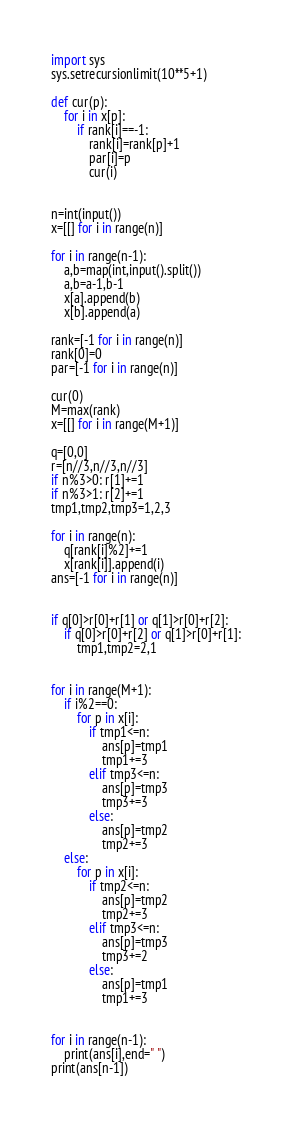<code> <loc_0><loc_0><loc_500><loc_500><_Python_>import sys
sys.setrecursionlimit(10**5+1)

def cur(p):
    for i in x[p]:
        if rank[i]==-1:
            rank[i]=rank[p]+1
            par[i]=p
            cur(i)


n=int(input())
x=[[] for i in range(n)]

for i in range(n-1):
    a,b=map(int,input().split())
    a,b=a-1,b-1
    x[a].append(b)
    x[b].append(a)

rank=[-1 for i in range(n)]
rank[0]=0
par=[-1 for i in range(n)]

cur(0)
M=max(rank)
x=[[] for i in range(M+1)]

q=[0,0]
r=[n//3,n//3,n//3]
if n%3>0: r[1]+=1
if n%3>1: r[2]+=1
tmp1,tmp2,tmp3=1,2,3

for i in range(n):
    q[rank[i]%2]+=1
    x[rank[i]].append(i)
ans=[-1 for i in range(n)]


if q[0]>r[0]+r[1] or q[1]>r[0]+r[2]:
    if q[0]>r[0]+r[2] or q[1]>r[0]+r[1]:
        tmp1,tmp2=2,1


for i in range(M+1):
    if i%2==0:
        for p in x[i]:
            if tmp1<=n:
                ans[p]=tmp1
                tmp1+=3
            elif tmp3<=n:
                ans[p]=tmp3
                tmp3+=3
            else:
                ans[p]=tmp2
                tmp2+=3
    else:
        for p in x[i]:
            if tmp2<=n:
                ans[p]=tmp2
                tmp2+=3
            elif tmp3<=n:
                ans[p]=tmp3
                tmp3+=2
            else:
                ans[p]=tmp1
                tmp1+=3


for i in range(n-1):
    print(ans[i],end=" ")
print(ans[n-1])</code> 